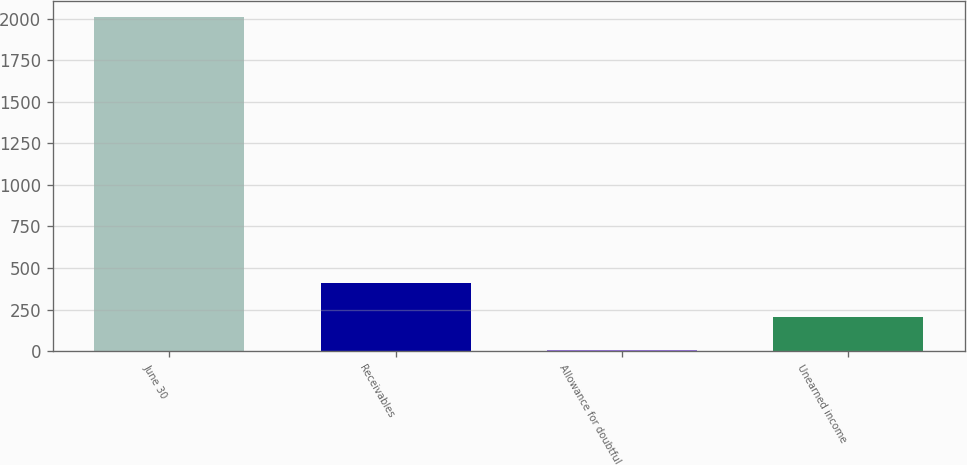<chart> <loc_0><loc_0><loc_500><loc_500><bar_chart><fcel>June 30<fcel>Receivables<fcel>Allowance for doubtful<fcel>Unearned income<nl><fcel>2008<fcel>407.92<fcel>7.9<fcel>207.91<nl></chart> 